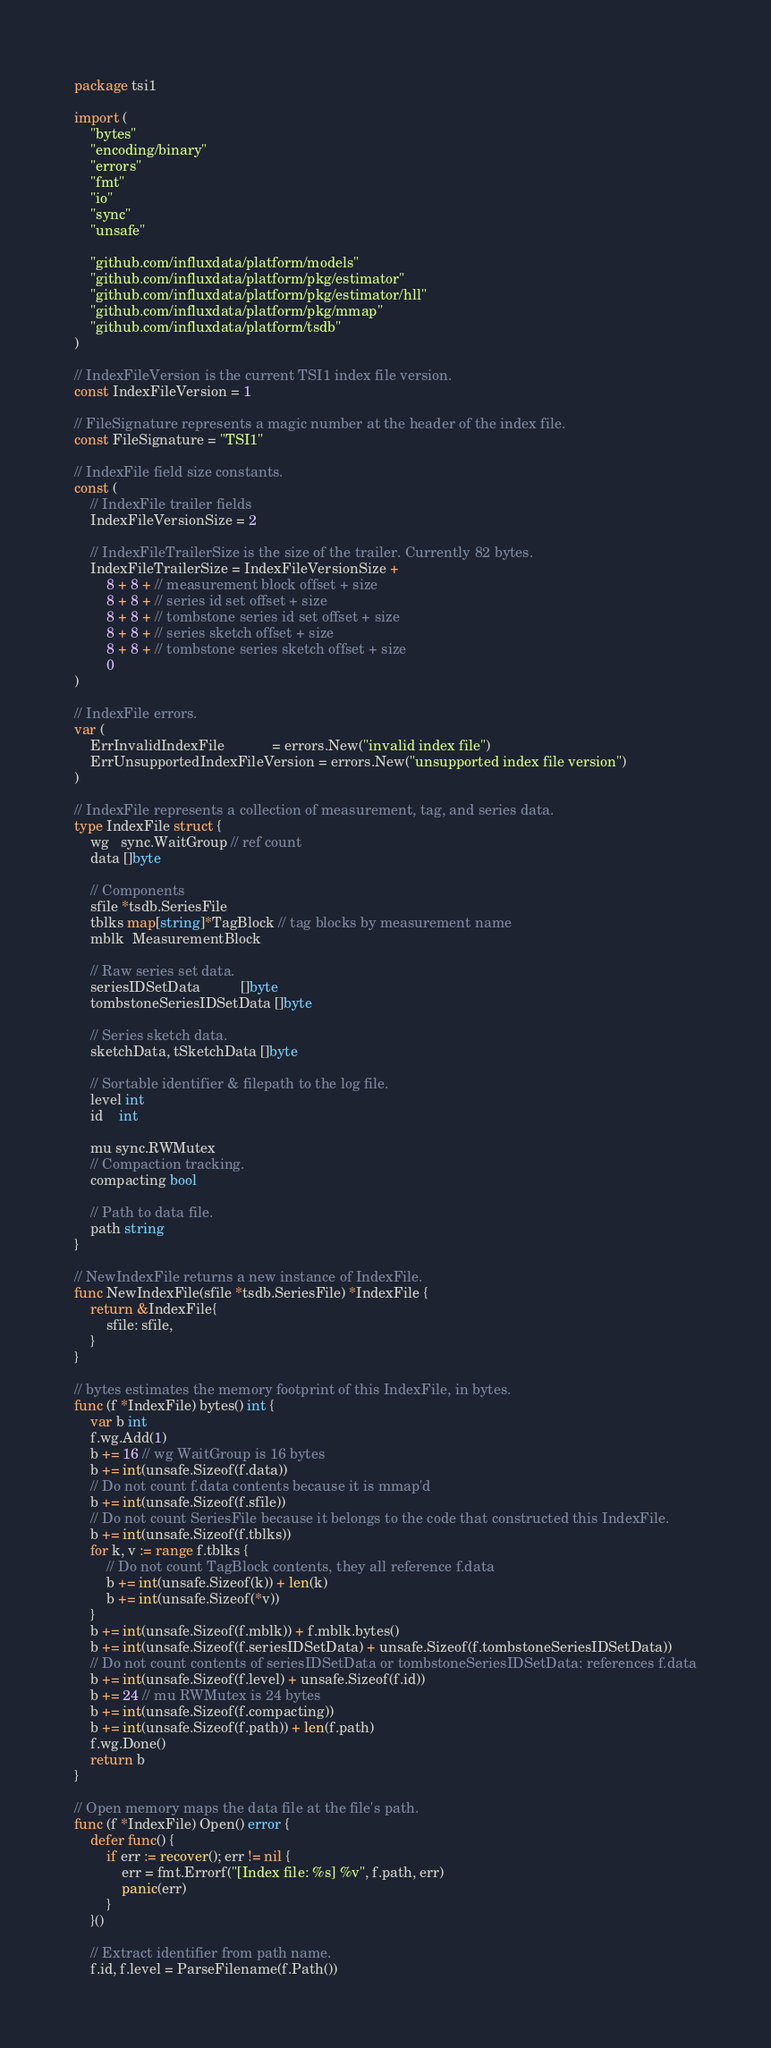Convert code to text. <code><loc_0><loc_0><loc_500><loc_500><_Go_>package tsi1

import (
	"bytes"
	"encoding/binary"
	"errors"
	"fmt"
	"io"
	"sync"
	"unsafe"

	"github.com/influxdata/platform/models"
	"github.com/influxdata/platform/pkg/estimator"
	"github.com/influxdata/platform/pkg/estimator/hll"
	"github.com/influxdata/platform/pkg/mmap"
	"github.com/influxdata/platform/tsdb"
)

// IndexFileVersion is the current TSI1 index file version.
const IndexFileVersion = 1

// FileSignature represents a magic number at the header of the index file.
const FileSignature = "TSI1"

// IndexFile field size constants.
const (
	// IndexFile trailer fields
	IndexFileVersionSize = 2

	// IndexFileTrailerSize is the size of the trailer. Currently 82 bytes.
	IndexFileTrailerSize = IndexFileVersionSize +
		8 + 8 + // measurement block offset + size
		8 + 8 + // series id set offset + size
		8 + 8 + // tombstone series id set offset + size
		8 + 8 + // series sketch offset + size
		8 + 8 + // tombstone series sketch offset + size
		0
)

// IndexFile errors.
var (
	ErrInvalidIndexFile            = errors.New("invalid index file")
	ErrUnsupportedIndexFileVersion = errors.New("unsupported index file version")
)

// IndexFile represents a collection of measurement, tag, and series data.
type IndexFile struct {
	wg   sync.WaitGroup // ref count
	data []byte

	// Components
	sfile *tsdb.SeriesFile
	tblks map[string]*TagBlock // tag blocks by measurement name
	mblk  MeasurementBlock

	// Raw series set data.
	seriesIDSetData          []byte
	tombstoneSeriesIDSetData []byte

	// Series sketch data.
	sketchData, tSketchData []byte

	// Sortable identifier & filepath to the log file.
	level int
	id    int

	mu sync.RWMutex
	// Compaction tracking.
	compacting bool

	// Path to data file.
	path string
}

// NewIndexFile returns a new instance of IndexFile.
func NewIndexFile(sfile *tsdb.SeriesFile) *IndexFile {
	return &IndexFile{
		sfile: sfile,
	}
}

// bytes estimates the memory footprint of this IndexFile, in bytes.
func (f *IndexFile) bytes() int {
	var b int
	f.wg.Add(1)
	b += 16 // wg WaitGroup is 16 bytes
	b += int(unsafe.Sizeof(f.data))
	// Do not count f.data contents because it is mmap'd
	b += int(unsafe.Sizeof(f.sfile))
	// Do not count SeriesFile because it belongs to the code that constructed this IndexFile.
	b += int(unsafe.Sizeof(f.tblks))
	for k, v := range f.tblks {
		// Do not count TagBlock contents, they all reference f.data
		b += int(unsafe.Sizeof(k)) + len(k)
		b += int(unsafe.Sizeof(*v))
	}
	b += int(unsafe.Sizeof(f.mblk)) + f.mblk.bytes()
	b += int(unsafe.Sizeof(f.seriesIDSetData) + unsafe.Sizeof(f.tombstoneSeriesIDSetData))
	// Do not count contents of seriesIDSetData or tombstoneSeriesIDSetData: references f.data
	b += int(unsafe.Sizeof(f.level) + unsafe.Sizeof(f.id))
	b += 24 // mu RWMutex is 24 bytes
	b += int(unsafe.Sizeof(f.compacting))
	b += int(unsafe.Sizeof(f.path)) + len(f.path)
	f.wg.Done()
	return b
}

// Open memory maps the data file at the file's path.
func (f *IndexFile) Open() error {
	defer func() {
		if err := recover(); err != nil {
			err = fmt.Errorf("[Index file: %s] %v", f.path, err)
			panic(err)
		}
	}()

	// Extract identifier from path name.
	f.id, f.level = ParseFilename(f.Path())
</code> 